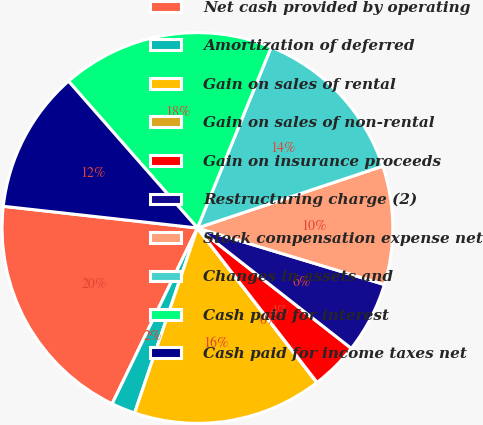Convert chart. <chart><loc_0><loc_0><loc_500><loc_500><pie_chart><fcel>Net cash provided by operating<fcel>Amortization of deferred<fcel>Gain on sales of rental<fcel>Gain on sales of non-rental<fcel>Gain on insurance proceeds<fcel>Restructuring charge (2)<fcel>Stock compensation expense net<fcel>Changes in assets and<fcel>Cash paid for interest<fcel>Cash paid for income taxes net<nl><fcel>19.58%<fcel>1.98%<fcel>15.67%<fcel>0.03%<fcel>3.94%<fcel>5.89%<fcel>9.8%<fcel>13.71%<fcel>17.63%<fcel>11.76%<nl></chart> 